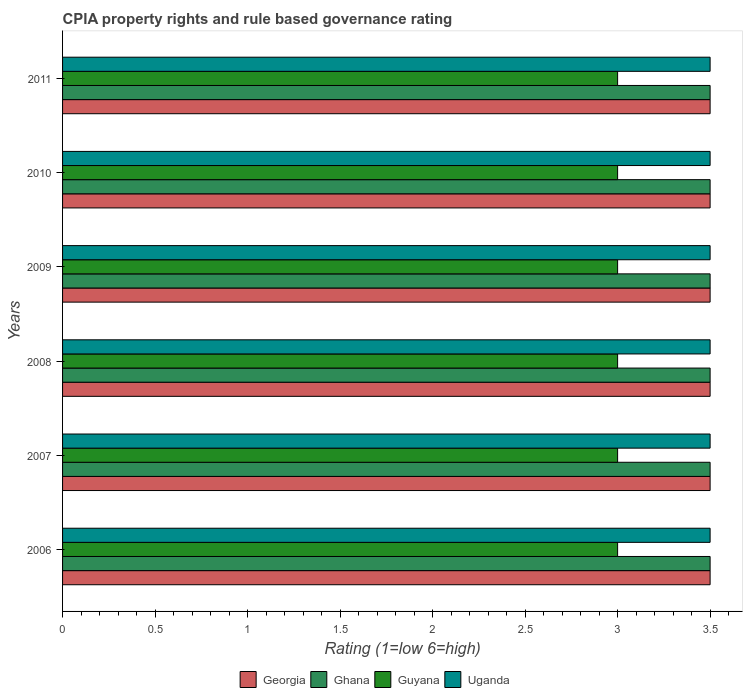How many groups of bars are there?
Your answer should be compact. 6. How many bars are there on the 6th tick from the bottom?
Your response must be concise. 4. What is the CPIA rating in Georgia in 2010?
Offer a very short reply. 3.5. Across all years, what is the minimum CPIA rating in Ghana?
Ensure brevity in your answer.  3.5. In which year was the CPIA rating in Uganda maximum?
Your response must be concise. 2006. What is the total CPIA rating in Uganda in the graph?
Ensure brevity in your answer.  21. What is the difference between the CPIA rating in Ghana in 2008 and that in 2011?
Keep it short and to the point. 0. What is the ratio of the CPIA rating in Georgia in 2006 to that in 2007?
Offer a very short reply. 1. Is the sum of the CPIA rating in Guyana in 2007 and 2011 greater than the maximum CPIA rating in Georgia across all years?
Your answer should be compact. Yes. Is it the case that in every year, the sum of the CPIA rating in Guyana and CPIA rating in Georgia is greater than the sum of CPIA rating in Ghana and CPIA rating in Uganda?
Your answer should be very brief. No. What does the 3rd bar from the bottom in 2009 represents?
Your response must be concise. Guyana. Is it the case that in every year, the sum of the CPIA rating in Uganda and CPIA rating in Georgia is greater than the CPIA rating in Guyana?
Offer a very short reply. Yes. How many bars are there?
Your response must be concise. 24. How many years are there in the graph?
Offer a terse response. 6. What is the difference between two consecutive major ticks on the X-axis?
Your response must be concise. 0.5. Does the graph contain grids?
Keep it short and to the point. No. How many legend labels are there?
Give a very brief answer. 4. What is the title of the graph?
Your answer should be compact. CPIA property rights and rule based governance rating. What is the label or title of the X-axis?
Your answer should be compact. Rating (1=low 6=high). What is the Rating (1=low 6=high) in Georgia in 2006?
Provide a succinct answer. 3.5. What is the Rating (1=low 6=high) in Ghana in 2006?
Provide a succinct answer. 3.5. What is the Rating (1=low 6=high) in Georgia in 2007?
Make the answer very short. 3.5. What is the Rating (1=low 6=high) of Ghana in 2007?
Give a very brief answer. 3.5. What is the Rating (1=low 6=high) in Uganda in 2007?
Keep it short and to the point. 3.5. What is the Rating (1=low 6=high) of Ghana in 2008?
Give a very brief answer. 3.5. What is the Rating (1=low 6=high) of Uganda in 2008?
Offer a very short reply. 3.5. What is the Rating (1=low 6=high) of Guyana in 2009?
Offer a terse response. 3. What is the Rating (1=low 6=high) of Uganda in 2009?
Make the answer very short. 3.5. What is the Rating (1=low 6=high) of Guyana in 2010?
Your answer should be compact. 3. What is the Rating (1=low 6=high) of Guyana in 2011?
Your answer should be compact. 3. Across all years, what is the maximum Rating (1=low 6=high) of Georgia?
Ensure brevity in your answer.  3.5. Across all years, what is the maximum Rating (1=low 6=high) of Ghana?
Give a very brief answer. 3.5. Across all years, what is the maximum Rating (1=low 6=high) of Guyana?
Offer a terse response. 3. Across all years, what is the maximum Rating (1=low 6=high) of Uganda?
Provide a short and direct response. 3.5. Across all years, what is the minimum Rating (1=low 6=high) in Ghana?
Give a very brief answer. 3.5. Across all years, what is the minimum Rating (1=low 6=high) in Guyana?
Make the answer very short. 3. Across all years, what is the minimum Rating (1=low 6=high) of Uganda?
Your answer should be very brief. 3.5. What is the total Rating (1=low 6=high) of Uganda in the graph?
Give a very brief answer. 21. What is the difference between the Rating (1=low 6=high) of Georgia in 2006 and that in 2007?
Give a very brief answer. 0. What is the difference between the Rating (1=low 6=high) of Ghana in 2006 and that in 2007?
Give a very brief answer. 0. What is the difference between the Rating (1=low 6=high) of Georgia in 2006 and that in 2008?
Your answer should be very brief. 0. What is the difference between the Rating (1=low 6=high) of Ghana in 2006 and that in 2008?
Provide a short and direct response. 0. What is the difference between the Rating (1=low 6=high) of Guyana in 2006 and that in 2008?
Your response must be concise. 0. What is the difference between the Rating (1=low 6=high) in Uganda in 2006 and that in 2008?
Provide a succinct answer. 0. What is the difference between the Rating (1=low 6=high) in Georgia in 2006 and that in 2009?
Offer a terse response. 0. What is the difference between the Rating (1=low 6=high) in Ghana in 2006 and that in 2009?
Give a very brief answer. 0. What is the difference between the Rating (1=low 6=high) in Guyana in 2006 and that in 2009?
Provide a succinct answer. 0. What is the difference between the Rating (1=low 6=high) of Georgia in 2006 and that in 2010?
Provide a short and direct response. 0. What is the difference between the Rating (1=low 6=high) of Ghana in 2006 and that in 2010?
Make the answer very short. 0. What is the difference between the Rating (1=low 6=high) of Guyana in 2006 and that in 2010?
Your response must be concise. 0. What is the difference between the Rating (1=low 6=high) of Georgia in 2007 and that in 2008?
Keep it short and to the point. 0. What is the difference between the Rating (1=low 6=high) of Ghana in 2007 and that in 2008?
Give a very brief answer. 0. What is the difference between the Rating (1=low 6=high) of Guyana in 2007 and that in 2008?
Provide a short and direct response. 0. What is the difference between the Rating (1=low 6=high) of Georgia in 2007 and that in 2009?
Offer a terse response. 0. What is the difference between the Rating (1=low 6=high) of Uganda in 2007 and that in 2009?
Ensure brevity in your answer.  0. What is the difference between the Rating (1=low 6=high) of Georgia in 2007 and that in 2010?
Keep it short and to the point. 0. What is the difference between the Rating (1=low 6=high) of Ghana in 2007 and that in 2010?
Your answer should be very brief. 0. What is the difference between the Rating (1=low 6=high) of Georgia in 2007 and that in 2011?
Offer a terse response. 0. What is the difference between the Rating (1=low 6=high) of Ghana in 2007 and that in 2011?
Offer a terse response. 0. What is the difference between the Rating (1=low 6=high) in Uganda in 2007 and that in 2011?
Your answer should be compact. 0. What is the difference between the Rating (1=low 6=high) in Guyana in 2008 and that in 2009?
Provide a short and direct response. 0. What is the difference between the Rating (1=low 6=high) in Guyana in 2008 and that in 2010?
Ensure brevity in your answer.  0. What is the difference between the Rating (1=low 6=high) in Georgia in 2008 and that in 2011?
Keep it short and to the point. 0. What is the difference between the Rating (1=low 6=high) of Uganda in 2009 and that in 2010?
Your answer should be compact. 0. What is the difference between the Rating (1=low 6=high) in Georgia in 2009 and that in 2011?
Your answer should be compact. 0. What is the difference between the Rating (1=low 6=high) in Ghana in 2009 and that in 2011?
Give a very brief answer. 0. What is the difference between the Rating (1=low 6=high) of Guyana in 2009 and that in 2011?
Give a very brief answer. 0. What is the difference between the Rating (1=low 6=high) in Georgia in 2010 and that in 2011?
Your answer should be compact. 0. What is the difference between the Rating (1=low 6=high) in Ghana in 2006 and the Rating (1=low 6=high) in Guyana in 2007?
Keep it short and to the point. 0.5. What is the difference between the Rating (1=low 6=high) in Guyana in 2006 and the Rating (1=low 6=high) in Uganda in 2007?
Keep it short and to the point. -0.5. What is the difference between the Rating (1=low 6=high) of Georgia in 2006 and the Rating (1=low 6=high) of Guyana in 2008?
Your response must be concise. 0.5. What is the difference between the Rating (1=low 6=high) in Ghana in 2006 and the Rating (1=low 6=high) in Guyana in 2008?
Keep it short and to the point. 0.5. What is the difference between the Rating (1=low 6=high) in Ghana in 2006 and the Rating (1=low 6=high) in Uganda in 2008?
Give a very brief answer. 0. What is the difference between the Rating (1=low 6=high) in Guyana in 2006 and the Rating (1=low 6=high) in Uganda in 2008?
Your answer should be compact. -0.5. What is the difference between the Rating (1=low 6=high) of Georgia in 2006 and the Rating (1=low 6=high) of Ghana in 2009?
Offer a terse response. 0. What is the difference between the Rating (1=low 6=high) of Ghana in 2006 and the Rating (1=low 6=high) of Guyana in 2009?
Your answer should be compact. 0.5. What is the difference between the Rating (1=low 6=high) in Ghana in 2006 and the Rating (1=low 6=high) in Uganda in 2009?
Offer a terse response. 0. What is the difference between the Rating (1=low 6=high) in Guyana in 2006 and the Rating (1=low 6=high) in Uganda in 2009?
Your answer should be very brief. -0.5. What is the difference between the Rating (1=low 6=high) of Georgia in 2006 and the Rating (1=low 6=high) of Ghana in 2011?
Make the answer very short. 0. What is the difference between the Rating (1=low 6=high) in Georgia in 2006 and the Rating (1=low 6=high) in Guyana in 2011?
Provide a short and direct response. 0.5. What is the difference between the Rating (1=low 6=high) in Georgia in 2006 and the Rating (1=low 6=high) in Uganda in 2011?
Provide a succinct answer. 0. What is the difference between the Rating (1=low 6=high) in Ghana in 2006 and the Rating (1=low 6=high) in Uganda in 2011?
Offer a very short reply. 0. What is the difference between the Rating (1=low 6=high) of Georgia in 2007 and the Rating (1=low 6=high) of Uganda in 2008?
Keep it short and to the point. 0. What is the difference between the Rating (1=low 6=high) of Ghana in 2007 and the Rating (1=low 6=high) of Guyana in 2008?
Keep it short and to the point. 0.5. What is the difference between the Rating (1=low 6=high) of Ghana in 2007 and the Rating (1=low 6=high) of Uganda in 2008?
Your answer should be very brief. 0. What is the difference between the Rating (1=low 6=high) in Guyana in 2007 and the Rating (1=low 6=high) in Uganda in 2008?
Offer a terse response. -0.5. What is the difference between the Rating (1=low 6=high) in Georgia in 2007 and the Rating (1=low 6=high) in Guyana in 2009?
Keep it short and to the point. 0.5. What is the difference between the Rating (1=low 6=high) of Ghana in 2007 and the Rating (1=low 6=high) of Guyana in 2009?
Provide a short and direct response. 0.5. What is the difference between the Rating (1=low 6=high) in Ghana in 2007 and the Rating (1=low 6=high) in Uganda in 2009?
Offer a very short reply. 0. What is the difference between the Rating (1=low 6=high) in Georgia in 2007 and the Rating (1=low 6=high) in Ghana in 2010?
Make the answer very short. 0. What is the difference between the Rating (1=low 6=high) of Ghana in 2007 and the Rating (1=low 6=high) of Guyana in 2010?
Keep it short and to the point. 0.5. What is the difference between the Rating (1=low 6=high) in Ghana in 2007 and the Rating (1=low 6=high) in Uganda in 2010?
Offer a very short reply. 0. What is the difference between the Rating (1=low 6=high) of Guyana in 2007 and the Rating (1=low 6=high) of Uganda in 2010?
Make the answer very short. -0.5. What is the difference between the Rating (1=low 6=high) of Georgia in 2007 and the Rating (1=low 6=high) of Guyana in 2011?
Offer a very short reply. 0.5. What is the difference between the Rating (1=low 6=high) of Ghana in 2007 and the Rating (1=low 6=high) of Guyana in 2011?
Your response must be concise. 0.5. What is the difference between the Rating (1=low 6=high) of Guyana in 2007 and the Rating (1=low 6=high) of Uganda in 2011?
Offer a very short reply. -0.5. What is the difference between the Rating (1=low 6=high) in Georgia in 2008 and the Rating (1=low 6=high) in Ghana in 2009?
Provide a succinct answer. 0. What is the difference between the Rating (1=low 6=high) of Georgia in 2008 and the Rating (1=low 6=high) of Guyana in 2009?
Give a very brief answer. 0.5. What is the difference between the Rating (1=low 6=high) in Georgia in 2008 and the Rating (1=low 6=high) in Uganda in 2009?
Give a very brief answer. 0. What is the difference between the Rating (1=low 6=high) of Ghana in 2008 and the Rating (1=low 6=high) of Guyana in 2009?
Offer a very short reply. 0.5. What is the difference between the Rating (1=low 6=high) in Georgia in 2008 and the Rating (1=low 6=high) in Uganda in 2010?
Make the answer very short. 0. What is the difference between the Rating (1=low 6=high) in Ghana in 2008 and the Rating (1=low 6=high) in Uganda in 2010?
Offer a very short reply. 0. What is the difference between the Rating (1=low 6=high) in Guyana in 2008 and the Rating (1=low 6=high) in Uganda in 2010?
Ensure brevity in your answer.  -0.5. What is the difference between the Rating (1=low 6=high) in Georgia in 2009 and the Rating (1=low 6=high) in Uganda in 2010?
Make the answer very short. 0. What is the difference between the Rating (1=low 6=high) of Ghana in 2009 and the Rating (1=low 6=high) of Guyana in 2010?
Offer a terse response. 0.5. What is the difference between the Rating (1=low 6=high) of Georgia in 2009 and the Rating (1=low 6=high) of Guyana in 2011?
Keep it short and to the point. 0.5. What is the difference between the Rating (1=low 6=high) in Georgia in 2009 and the Rating (1=low 6=high) in Uganda in 2011?
Ensure brevity in your answer.  0. What is the difference between the Rating (1=low 6=high) in Ghana in 2009 and the Rating (1=low 6=high) in Guyana in 2011?
Offer a very short reply. 0.5. What is the difference between the Rating (1=low 6=high) of Ghana in 2009 and the Rating (1=low 6=high) of Uganda in 2011?
Make the answer very short. 0. What is the difference between the Rating (1=low 6=high) in Guyana in 2009 and the Rating (1=low 6=high) in Uganda in 2011?
Ensure brevity in your answer.  -0.5. What is the difference between the Rating (1=low 6=high) in Georgia in 2010 and the Rating (1=low 6=high) in Uganda in 2011?
Ensure brevity in your answer.  0. What is the difference between the Rating (1=low 6=high) of Ghana in 2010 and the Rating (1=low 6=high) of Uganda in 2011?
Give a very brief answer. 0. What is the average Rating (1=low 6=high) of Georgia per year?
Offer a very short reply. 3.5. What is the average Rating (1=low 6=high) of Guyana per year?
Your answer should be very brief. 3. What is the average Rating (1=low 6=high) in Uganda per year?
Provide a succinct answer. 3.5. In the year 2006, what is the difference between the Rating (1=low 6=high) in Georgia and Rating (1=low 6=high) in Ghana?
Provide a succinct answer. 0. In the year 2006, what is the difference between the Rating (1=low 6=high) in Georgia and Rating (1=low 6=high) in Uganda?
Your answer should be very brief. 0. In the year 2006, what is the difference between the Rating (1=low 6=high) of Ghana and Rating (1=low 6=high) of Guyana?
Give a very brief answer. 0.5. In the year 2006, what is the difference between the Rating (1=low 6=high) in Ghana and Rating (1=low 6=high) in Uganda?
Your response must be concise. 0. In the year 2006, what is the difference between the Rating (1=low 6=high) in Guyana and Rating (1=low 6=high) in Uganda?
Your response must be concise. -0.5. In the year 2007, what is the difference between the Rating (1=low 6=high) in Ghana and Rating (1=low 6=high) in Guyana?
Your answer should be very brief. 0.5. In the year 2008, what is the difference between the Rating (1=low 6=high) in Georgia and Rating (1=low 6=high) in Ghana?
Offer a terse response. 0. In the year 2008, what is the difference between the Rating (1=low 6=high) of Georgia and Rating (1=low 6=high) of Guyana?
Offer a terse response. 0.5. In the year 2008, what is the difference between the Rating (1=low 6=high) in Georgia and Rating (1=low 6=high) in Uganda?
Give a very brief answer. 0. In the year 2008, what is the difference between the Rating (1=low 6=high) of Ghana and Rating (1=low 6=high) of Guyana?
Keep it short and to the point. 0.5. In the year 2008, what is the difference between the Rating (1=low 6=high) in Guyana and Rating (1=low 6=high) in Uganda?
Make the answer very short. -0.5. In the year 2009, what is the difference between the Rating (1=low 6=high) of Georgia and Rating (1=low 6=high) of Ghana?
Your answer should be compact. 0. In the year 2009, what is the difference between the Rating (1=low 6=high) of Georgia and Rating (1=low 6=high) of Uganda?
Make the answer very short. 0. In the year 2009, what is the difference between the Rating (1=low 6=high) of Guyana and Rating (1=low 6=high) of Uganda?
Provide a succinct answer. -0.5. In the year 2010, what is the difference between the Rating (1=low 6=high) of Georgia and Rating (1=low 6=high) of Ghana?
Provide a short and direct response. 0. In the year 2010, what is the difference between the Rating (1=low 6=high) of Georgia and Rating (1=low 6=high) of Guyana?
Make the answer very short. 0.5. In the year 2010, what is the difference between the Rating (1=low 6=high) of Ghana and Rating (1=low 6=high) of Guyana?
Your answer should be compact. 0.5. In the year 2010, what is the difference between the Rating (1=low 6=high) in Ghana and Rating (1=low 6=high) in Uganda?
Provide a succinct answer. 0. In the year 2010, what is the difference between the Rating (1=low 6=high) in Guyana and Rating (1=low 6=high) in Uganda?
Provide a short and direct response. -0.5. In the year 2011, what is the difference between the Rating (1=low 6=high) in Georgia and Rating (1=low 6=high) in Ghana?
Keep it short and to the point. 0. In the year 2011, what is the difference between the Rating (1=low 6=high) of Georgia and Rating (1=low 6=high) of Guyana?
Offer a terse response. 0.5. In the year 2011, what is the difference between the Rating (1=low 6=high) in Ghana and Rating (1=low 6=high) in Uganda?
Make the answer very short. 0. In the year 2011, what is the difference between the Rating (1=low 6=high) in Guyana and Rating (1=low 6=high) in Uganda?
Your answer should be compact. -0.5. What is the ratio of the Rating (1=low 6=high) of Uganda in 2006 to that in 2007?
Keep it short and to the point. 1. What is the ratio of the Rating (1=low 6=high) in Guyana in 2006 to that in 2008?
Your answer should be very brief. 1. What is the ratio of the Rating (1=low 6=high) in Uganda in 2006 to that in 2008?
Ensure brevity in your answer.  1. What is the ratio of the Rating (1=low 6=high) of Uganda in 2006 to that in 2009?
Offer a terse response. 1. What is the ratio of the Rating (1=low 6=high) of Georgia in 2006 to that in 2010?
Your answer should be very brief. 1. What is the ratio of the Rating (1=low 6=high) of Guyana in 2006 to that in 2010?
Make the answer very short. 1. What is the ratio of the Rating (1=low 6=high) in Guyana in 2006 to that in 2011?
Keep it short and to the point. 1. What is the ratio of the Rating (1=low 6=high) of Guyana in 2007 to that in 2008?
Offer a very short reply. 1. What is the ratio of the Rating (1=low 6=high) in Guyana in 2007 to that in 2009?
Your response must be concise. 1. What is the ratio of the Rating (1=low 6=high) of Uganda in 2007 to that in 2009?
Your answer should be compact. 1. What is the ratio of the Rating (1=low 6=high) in Georgia in 2007 to that in 2010?
Ensure brevity in your answer.  1. What is the ratio of the Rating (1=low 6=high) of Ghana in 2007 to that in 2010?
Offer a terse response. 1. What is the ratio of the Rating (1=low 6=high) in Uganda in 2007 to that in 2010?
Offer a very short reply. 1. What is the ratio of the Rating (1=low 6=high) in Ghana in 2007 to that in 2011?
Your answer should be very brief. 1. What is the ratio of the Rating (1=low 6=high) of Guyana in 2007 to that in 2011?
Give a very brief answer. 1. What is the ratio of the Rating (1=low 6=high) of Uganda in 2007 to that in 2011?
Provide a short and direct response. 1. What is the ratio of the Rating (1=low 6=high) in Ghana in 2008 to that in 2009?
Provide a succinct answer. 1. What is the ratio of the Rating (1=low 6=high) in Guyana in 2008 to that in 2009?
Offer a terse response. 1. What is the ratio of the Rating (1=low 6=high) in Uganda in 2008 to that in 2011?
Your response must be concise. 1. What is the ratio of the Rating (1=low 6=high) in Georgia in 2009 to that in 2010?
Offer a very short reply. 1. What is the ratio of the Rating (1=low 6=high) in Ghana in 2009 to that in 2010?
Offer a very short reply. 1. What is the ratio of the Rating (1=low 6=high) in Ghana in 2009 to that in 2011?
Offer a very short reply. 1. What is the ratio of the Rating (1=low 6=high) in Guyana in 2009 to that in 2011?
Keep it short and to the point. 1. What is the ratio of the Rating (1=low 6=high) in Uganda in 2009 to that in 2011?
Keep it short and to the point. 1. What is the ratio of the Rating (1=low 6=high) of Guyana in 2010 to that in 2011?
Make the answer very short. 1. What is the ratio of the Rating (1=low 6=high) of Uganda in 2010 to that in 2011?
Your response must be concise. 1. What is the difference between the highest and the second highest Rating (1=low 6=high) of Georgia?
Ensure brevity in your answer.  0. What is the difference between the highest and the second highest Rating (1=low 6=high) of Ghana?
Offer a very short reply. 0. What is the difference between the highest and the lowest Rating (1=low 6=high) in Ghana?
Your response must be concise. 0. What is the difference between the highest and the lowest Rating (1=low 6=high) in Uganda?
Your response must be concise. 0. 